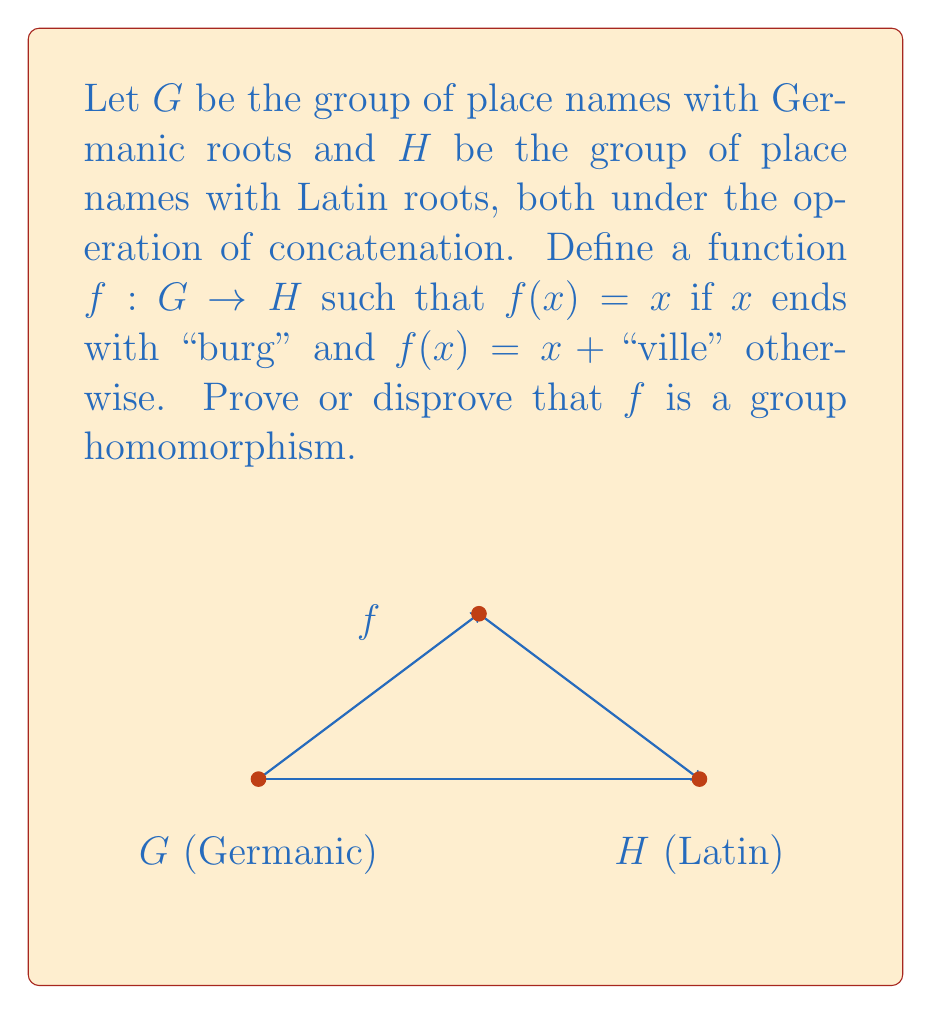Give your solution to this math problem. To prove or disprove that $f$ is a group homomorphism, we need to check if it satisfies the homomorphism property: $f(xy) = f(x)f(y)$ for all $x, y \in G$.

Let's consider two cases:

1) When both $x$ and $y$ end with "burg":
   $f(xy) = xy$ (since $xy$ ends with "burg")
   $f(x)f(y) = xy$
   In this case, $f(xy) = f(x)f(y)$

2) When at least one of $x$ or $y$ does not end with "burg":
   $f(xy) = xy + "ville"$ (since $xy$ doesn't end with "burg")
   $f(x)f(y)$ could be one of:
   - $(x + "ville")(y + "ville")$ if neither ends with "burg"
   - $x(y + "ville")$ if $x$ ends with "burg" but $y$ doesn't
   - $(x + "ville")y$ if $y$ ends with "burg" but $x$ doesn't

In all these subcases, $f(xy) \neq f(x)f(y)$

Since we've found cases where the homomorphism property doesn't hold, we can conclude that $f$ is not a group homomorphism.
Answer: $f$ is not a group homomorphism. 